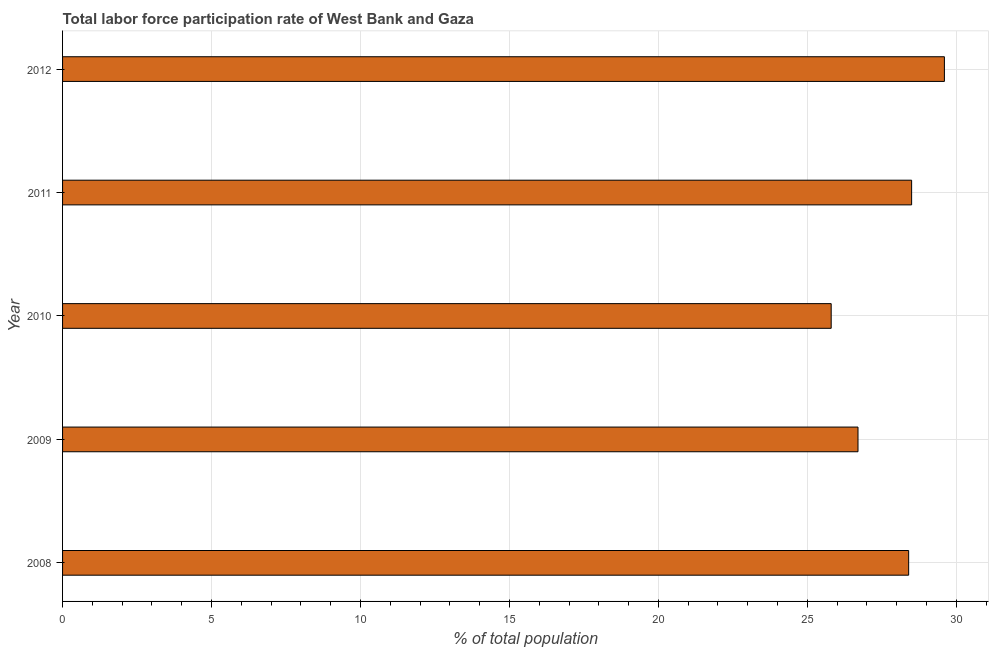Does the graph contain grids?
Your answer should be very brief. Yes. What is the title of the graph?
Offer a very short reply. Total labor force participation rate of West Bank and Gaza. What is the label or title of the X-axis?
Provide a succinct answer. % of total population. What is the total labor force participation rate in 2012?
Make the answer very short. 29.6. Across all years, what is the maximum total labor force participation rate?
Provide a succinct answer. 29.6. Across all years, what is the minimum total labor force participation rate?
Offer a terse response. 25.8. What is the sum of the total labor force participation rate?
Your answer should be compact. 139. What is the difference between the total labor force participation rate in 2011 and 2012?
Offer a terse response. -1.1. What is the average total labor force participation rate per year?
Keep it short and to the point. 27.8. What is the median total labor force participation rate?
Offer a terse response. 28.4. Do a majority of the years between 2009 and 2010 (inclusive) have total labor force participation rate greater than 19 %?
Your answer should be compact. Yes. What is the ratio of the total labor force participation rate in 2008 to that in 2011?
Ensure brevity in your answer.  1. Is the total labor force participation rate in 2010 less than that in 2012?
Your response must be concise. Yes. What is the difference between the highest and the second highest total labor force participation rate?
Provide a short and direct response. 1.1. In how many years, is the total labor force participation rate greater than the average total labor force participation rate taken over all years?
Give a very brief answer. 3. Are all the bars in the graph horizontal?
Ensure brevity in your answer.  Yes. What is the % of total population in 2008?
Your response must be concise. 28.4. What is the % of total population of 2009?
Provide a short and direct response. 26.7. What is the % of total population of 2010?
Your response must be concise. 25.8. What is the % of total population in 2012?
Keep it short and to the point. 29.6. What is the difference between the % of total population in 2008 and 2010?
Make the answer very short. 2.6. What is the difference between the % of total population in 2008 and 2011?
Provide a short and direct response. -0.1. What is the difference between the % of total population in 2008 and 2012?
Your answer should be compact. -1.2. What is the difference between the % of total population in 2009 and 2010?
Your response must be concise. 0.9. What is the difference between the % of total population in 2009 and 2012?
Keep it short and to the point. -2.9. What is the difference between the % of total population in 2010 and 2012?
Provide a short and direct response. -3.8. What is the ratio of the % of total population in 2008 to that in 2009?
Offer a very short reply. 1.06. What is the ratio of the % of total population in 2008 to that in 2010?
Give a very brief answer. 1.1. What is the ratio of the % of total population in 2008 to that in 2012?
Your response must be concise. 0.96. What is the ratio of the % of total population in 2009 to that in 2010?
Offer a terse response. 1.03. What is the ratio of the % of total population in 2009 to that in 2011?
Give a very brief answer. 0.94. What is the ratio of the % of total population in 2009 to that in 2012?
Ensure brevity in your answer.  0.9. What is the ratio of the % of total population in 2010 to that in 2011?
Ensure brevity in your answer.  0.91. What is the ratio of the % of total population in 2010 to that in 2012?
Your answer should be compact. 0.87. 